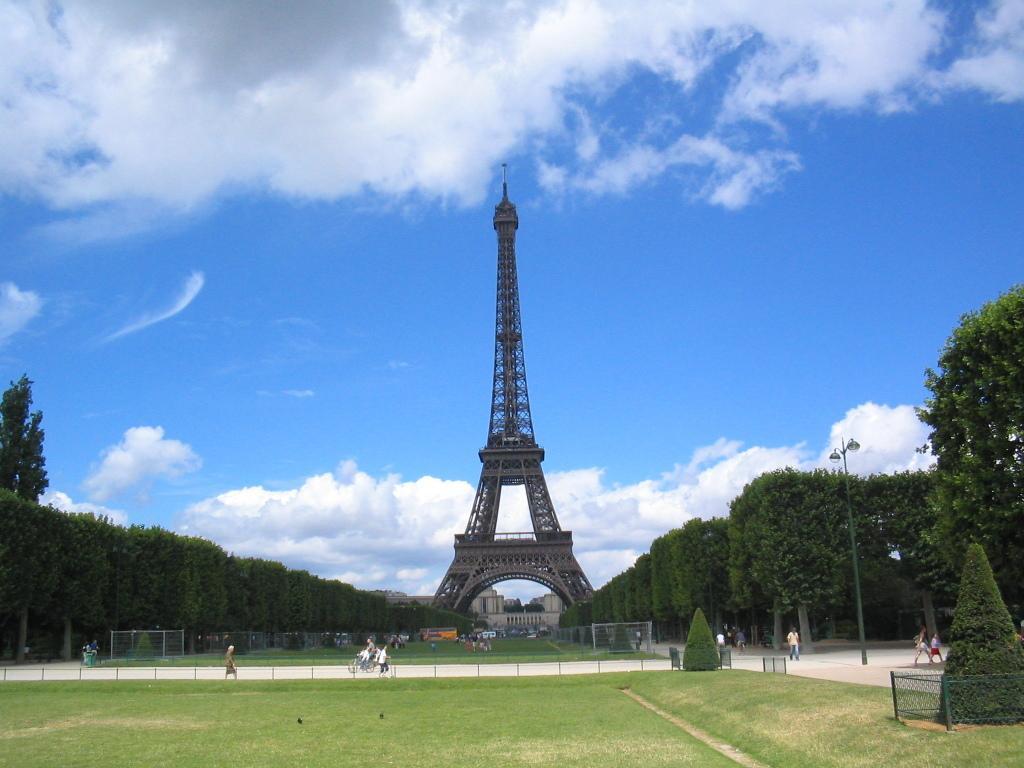Can you describe this image briefly? In this picture I can see there are few people walking on the streets and there is grass and plants here. In the backdrop there is a tower and there are trees and the sky is clear. 